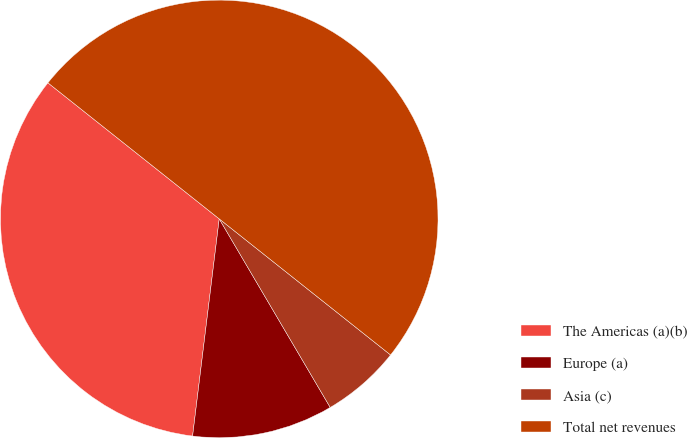<chart> <loc_0><loc_0><loc_500><loc_500><pie_chart><fcel>The Americas (a)(b)<fcel>Europe (a)<fcel>Asia (c)<fcel>Total net revenues<nl><fcel>33.74%<fcel>10.41%<fcel>5.85%<fcel>50.0%<nl></chart> 